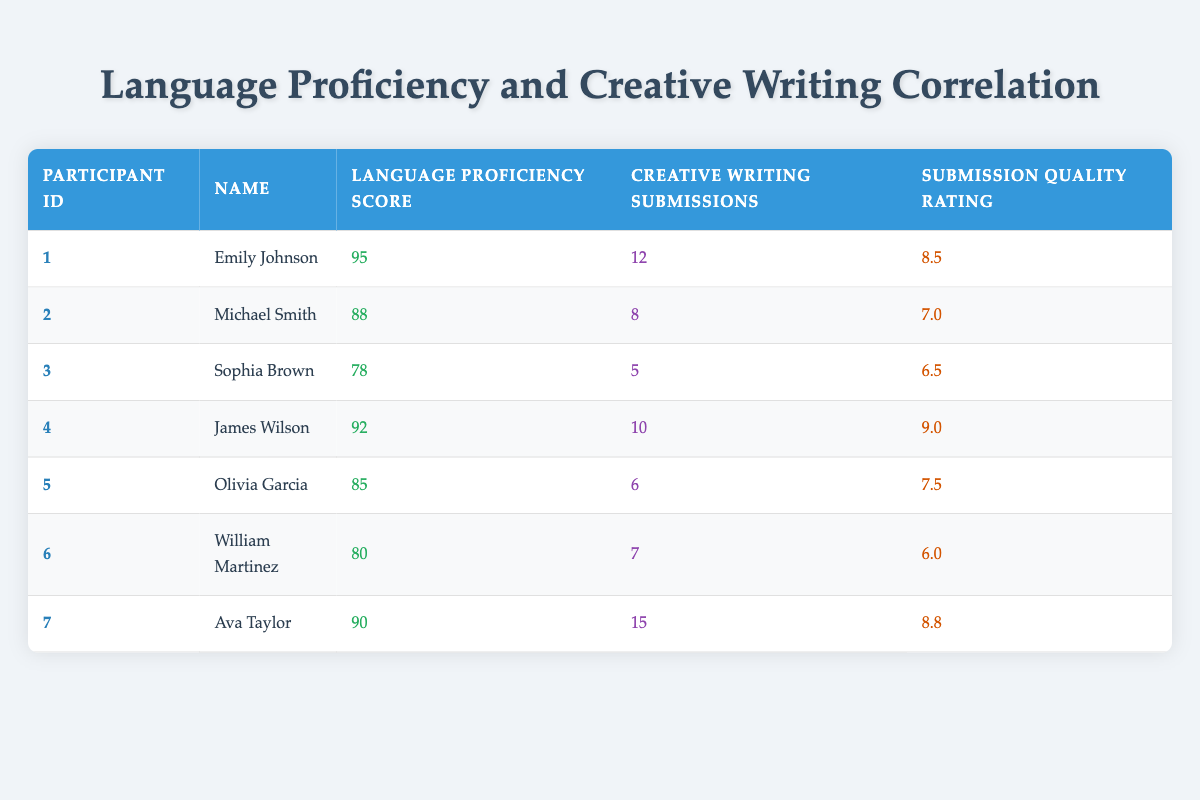What is the language proficiency score of Emily Johnson? Emily Johnson's row in the table shows that her language proficiency score is 95.
Answer: 95 How many creative writing submissions did Ava Taylor make? According to the table, Ava Taylor's row states that she made 15 creative writing submissions.
Answer: 15 Is it true that Sophia Brown has a higher submission quality rating than Olivia Garcia? Sophia Brown's submission quality rating is 6.5, while Olivia Garcia's is 7.5. Since 6.5 is less than 7.5, this statement is false.
Answer: No What is the average language proficiency score of all participants? To find the average, we first add up all the language proficiency scores: (95 + 88 + 78 + 92 + 85 + 80 + 90) = 518. There are 7 participants, so the average is 518 / 7 = 74.
Answer: 74 Which participant made the least number of creative writing submissions? Looking at the creative writing submissions column, Sophia Brown made the least with 5 submissions.
Answer: Sophia Brown What is the total number of creative writing submissions for participants with a language proficiency score above 90? The participants with scores above 90 are Emily Johnson (12), James Wilson (10), and Ava Taylor (15). Their total submissions are 12 + 10 + 15 = 37.
Answer: 37 Did any participant submit more than 10 creative writing pieces? Inspecting the creative writing submissions column reveals Ava Taylor submitted 15, which is more than 10. Thus, the answer is yes.
Answer: Yes What is the difference between the highest and lowest submission quality ratings? The highest submission quality rating in the table is 9.0 (James Wilson) and the lowest is 6.0 (William Martinez). Calculating the difference: 9.0 - 6.0 = 3.0.
Answer: 3.0 How many participants had a language proficiency score of 85 or lower? The participants with scores of 85 or lower are Sophia Brown (78), William Martinez (80), and Olivia Garcia (85), totaling 3 participants.
Answer: 3 